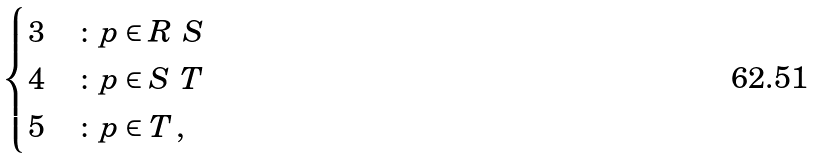Convert formula to latex. <formula><loc_0><loc_0><loc_500><loc_500>\begin{cases} 3 & \colon p \in R \ S \\ 4 & \colon p \in S \ T \\ 5 & \colon p \in T \, , \end{cases}</formula> 